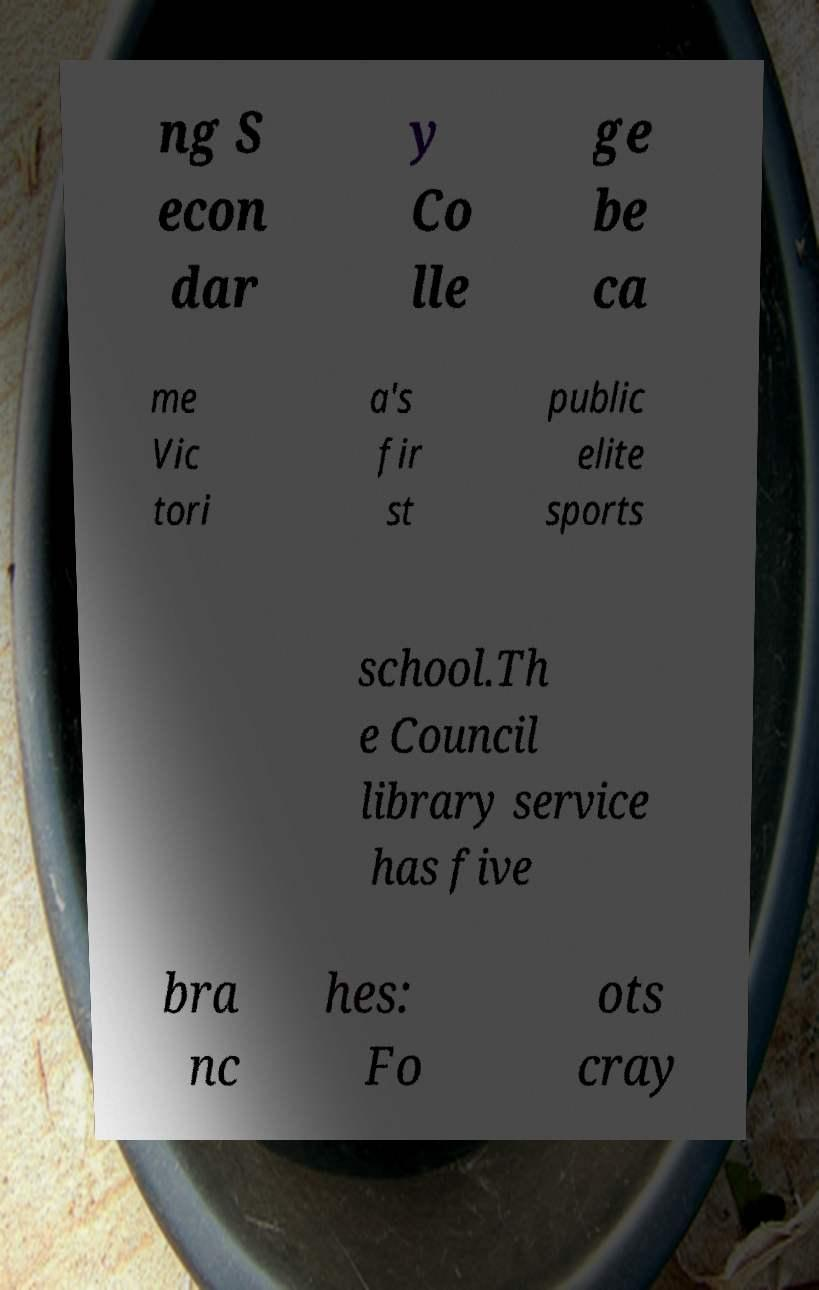What messages or text are displayed in this image? I need them in a readable, typed format. ng S econ dar y Co lle ge be ca me Vic tori a's fir st public elite sports school.Th e Council library service has five bra nc hes: Fo ots cray 